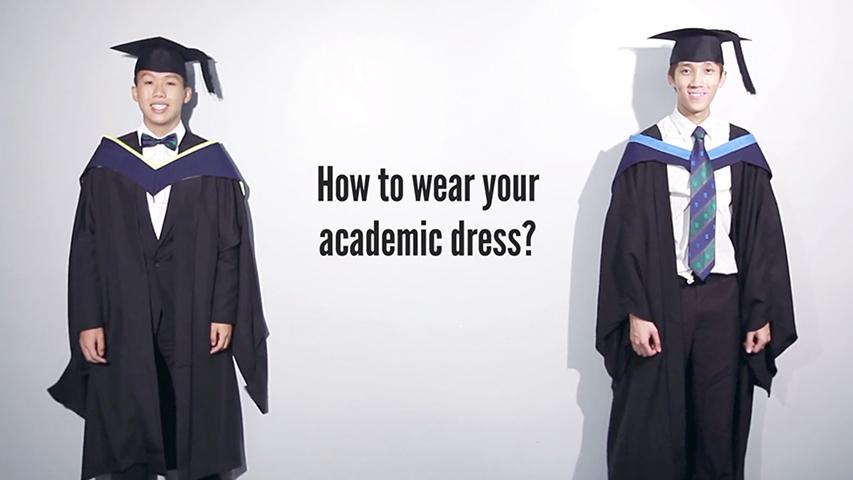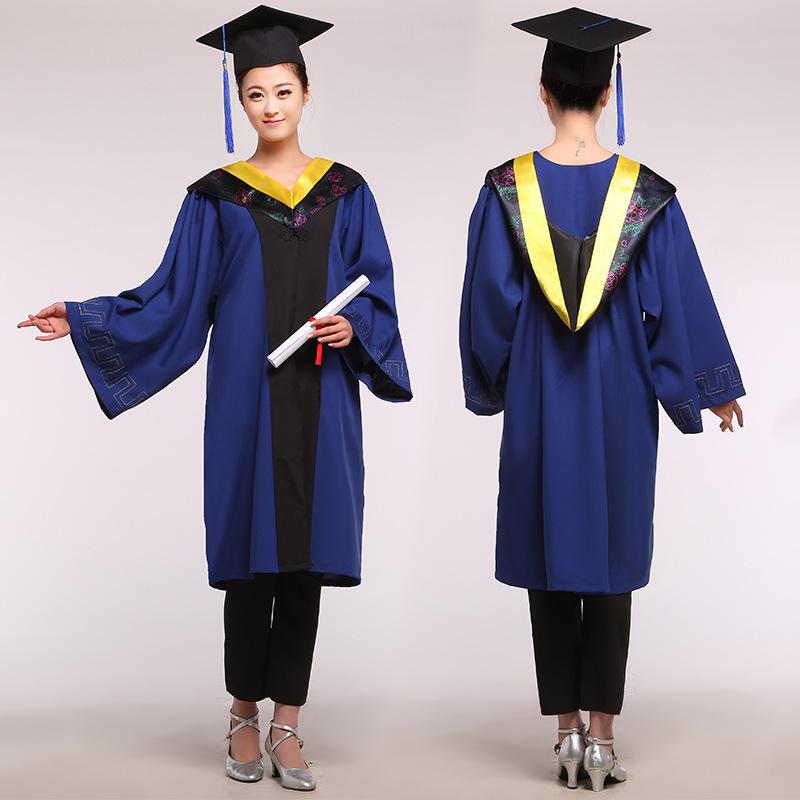The first image is the image on the left, the second image is the image on the right. Examine the images to the left and right. Is the description "One out of four graduates has her back turned towards the camera." accurate? Answer yes or no. Yes. The first image is the image on the left, the second image is the image on the right. Analyze the images presented: Is the assertion "In one image, a graduation gown model is wearing silver high heeled shoes." valid? Answer yes or no. Yes. 